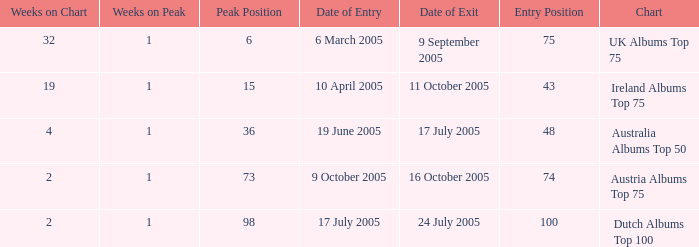What is the exit date for the Dutch Albums Top 100 Chart? 24 July 2005. 